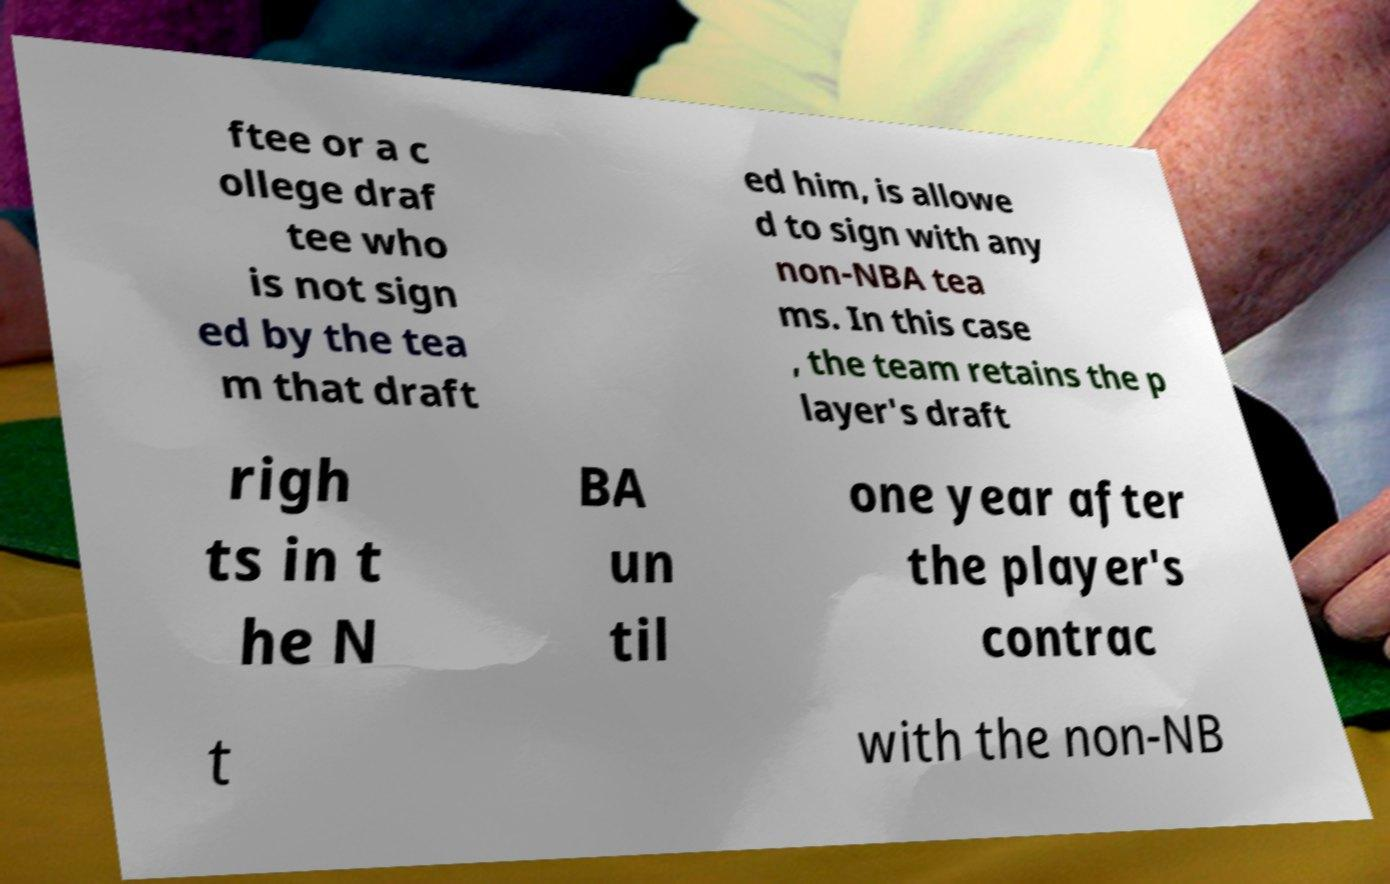I need the written content from this picture converted into text. Can you do that? ftee or a c ollege draf tee who is not sign ed by the tea m that draft ed him, is allowe d to sign with any non-NBA tea ms. In this case , the team retains the p layer's draft righ ts in t he N BA un til one year after the player's contrac t with the non-NB 